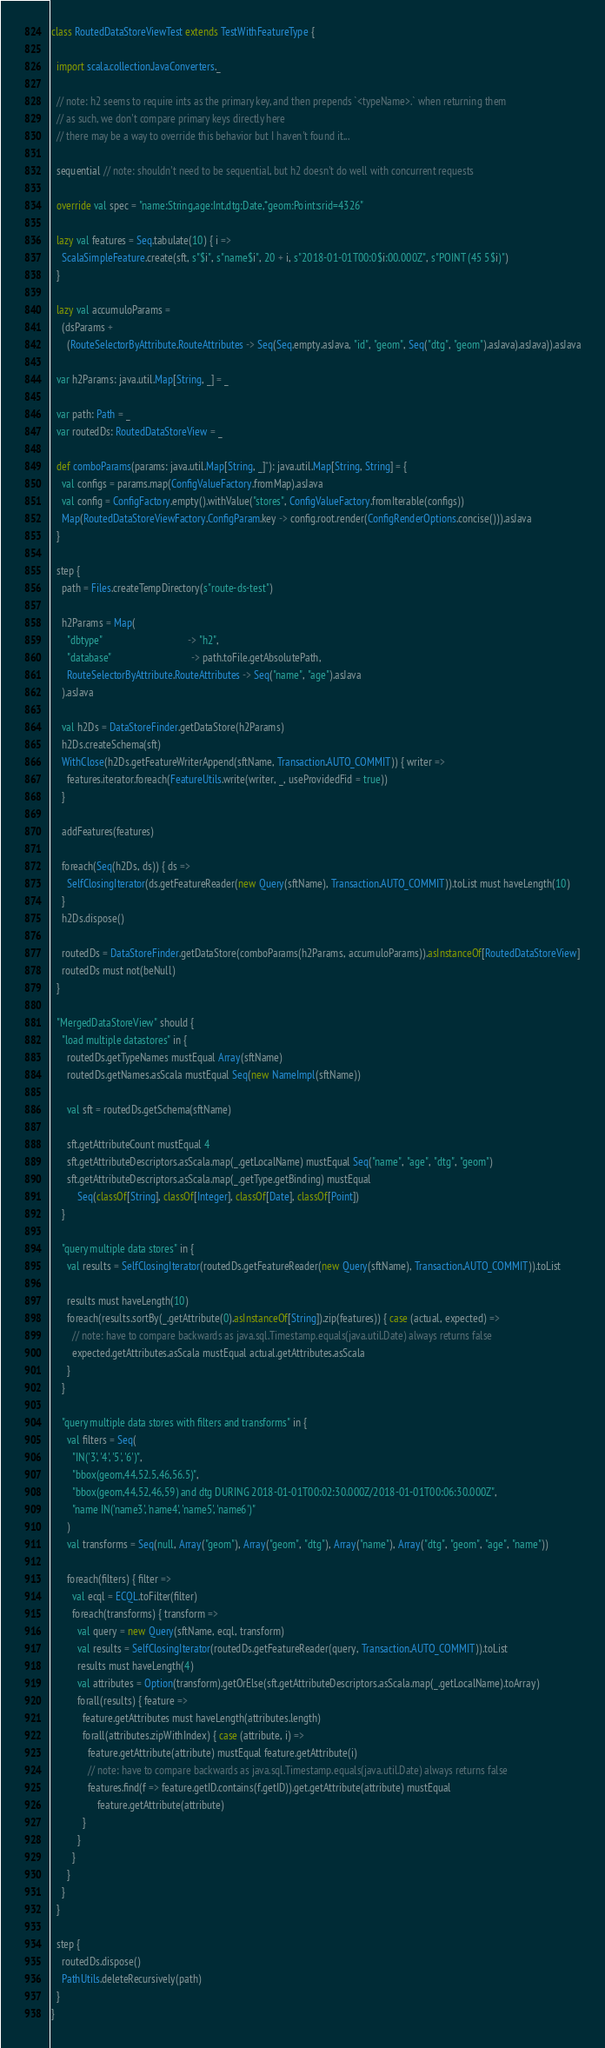<code> <loc_0><loc_0><loc_500><loc_500><_Scala_>class RoutedDataStoreViewTest extends TestWithFeatureType {

  import scala.collection.JavaConverters._

  // note: h2 seems to require ints as the primary key, and then prepends `<typeName>.` when returning them
  // as such, we don't compare primary keys directly here
  // there may be a way to override this behavior but I haven't found it...

  sequential // note: shouldn't need to be sequential, but h2 doesn't do well with concurrent requests

  override val spec = "name:String,age:Int,dtg:Date,*geom:Point:srid=4326"

  lazy val features = Seq.tabulate(10) { i =>
    ScalaSimpleFeature.create(sft, s"$i", s"name$i", 20 + i, s"2018-01-01T00:0$i:00.000Z", s"POINT (45 5$i)")
  }

  lazy val accumuloParams =
    (dsParams +
      (RouteSelectorByAttribute.RouteAttributes -> Seq(Seq.empty.asJava, "id", "geom", Seq("dtg", "geom").asJava).asJava)).asJava

  var h2Params: java.util.Map[String, _] = _

  var path: Path = _
  var routedDs: RoutedDataStoreView = _

  def comboParams(params: java.util.Map[String, _]*): java.util.Map[String, String] = {
    val configs = params.map(ConfigValueFactory.fromMap).asJava
    val config = ConfigFactory.empty().withValue("stores", ConfigValueFactory.fromIterable(configs))
    Map(RoutedDataStoreViewFactory.ConfigParam.key -> config.root.render(ConfigRenderOptions.concise())).asJava
  }

  step {
    path = Files.createTempDirectory(s"route-ds-test")

    h2Params = Map(
      "dbtype"                                 -> "h2",
      "database"                               -> path.toFile.getAbsolutePath,
      RouteSelectorByAttribute.RouteAttributes -> Seq("name", "age").asJava
    ).asJava

    val h2Ds = DataStoreFinder.getDataStore(h2Params)
    h2Ds.createSchema(sft)
    WithClose(h2Ds.getFeatureWriterAppend(sftName, Transaction.AUTO_COMMIT)) { writer =>
      features.iterator.foreach(FeatureUtils.write(writer, _, useProvidedFid = true))
    }

    addFeatures(features)

    foreach(Seq(h2Ds, ds)) { ds =>
      SelfClosingIterator(ds.getFeatureReader(new Query(sftName), Transaction.AUTO_COMMIT)).toList must haveLength(10)
    }
    h2Ds.dispose()

    routedDs = DataStoreFinder.getDataStore(comboParams(h2Params, accumuloParams)).asInstanceOf[RoutedDataStoreView]
    routedDs must not(beNull)
  }

  "MergedDataStoreView" should {
    "load multiple datastores" in {
      routedDs.getTypeNames mustEqual Array(sftName)
      routedDs.getNames.asScala mustEqual Seq(new NameImpl(sftName))

      val sft = routedDs.getSchema(sftName)

      sft.getAttributeCount mustEqual 4
      sft.getAttributeDescriptors.asScala.map(_.getLocalName) mustEqual Seq("name", "age", "dtg", "geom")
      sft.getAttributeDescriptors.asScala.map(_.getType.getBinding) mustEqual
          Seq(classOf[String], classOf[Integer], classOf[Date], classOf[Point])
    }

    "query multiple data stores" in {
      val results = SelfClosingIterator(routedDs.getFeatureReader(new Query(sftName), Transaction.AUTO_COMMIT)).toList

      results must haveLength(10)
      foreach(results.sortBy(_.getAttribute(0).asInstanceOf[String]).zip(features)) { case (actual, expected) =>
        // note: have to compare backwards as java.sql.Timestamp.equals(java.util.Date) always returns false
        expected.getAttributes.asScala mustEqual actual.getAttributes.asScala
      }
    }

    "query multiple data stores with filters and transforms" in {
      val filters = Seq(
        "IN('3', '4', '5', '6')",
        "bbox(geom,44,52.5,46,56.5)",
        "bbox(geom,44,52,46,59) and dtg DURING 2018-01-01T00:02:30.000Z/2018-01-01T00:06:30.000Z",
        "name IN('name3', 'name4', 'name5', 'name6')"
      )
      val transforms = Seq(null, Array("geom"), Array("geom", "dtg"), Array("name"), Array("dtg", "geom", "age", "name"))

      foreach(filters) { filter =>
        val ecql = ECQL.toFilter(filter)
        foreach(transforms) { transform =>
          val query = new Query(sftName, ecql, transform)
          val results = SelfClosingIterator(routedDs.getFeatureReader(query, Transaction.AUTO_COMMIT)).toList
          results must haveLength(4)
          val attributes = Option(transform).getOrElse(sft.getAttributeDescriptors.asScala.map(_.getLocalName).toArray)
          forall(results) { feature =>
            feature.getAttributes must haveLength(attributes.length)
            forall(attributes.zipWithIndex) { case (attribute, i) =>
              feature.getAttribute(attribute) mustEqual feature.getAttribute(i)
              // note: have to compare backwards as java.sql.Timestamp.equals(java.util.Date) always returns false
              features.find(f => feature.getID.contains(f.getID)).get.getAttribute(attribute) mustEqual
                  feature.getAttribute(attribute)
            }
          }
        }
      }
    }
  }

  step {
    routedDs.dispose()
    PathUtils.deleteRecursively(path)
  }
}


</code> 